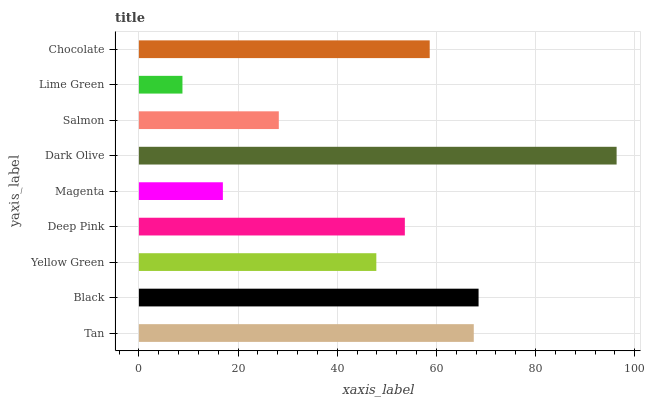Is Lime Green the minimum?
Answer yes or no. Yes. Is Dark Olive the maximum?
Answer yes or no. Yes. Is Black the minimum?
Answer yes or no. No. Is Black the maximum?
Answer yes or no. No. Is Black greater than Tan?
Answer yes or no. Yes. Is Tan less than Black?
Answer yes or no. Yes. Is Tan greater than Black?
Answer yes or no. No. Is Black less than Tan?
Answer yes or no. No. Is Deep Pink the high median?
Answer yes or no. Yes. Is Deep Pink the low median?
Answer yes or no. Yes. Is Lime Green the high median?
Answer yes or no. No. Is Black the low median?
Answer yes or no. No. 